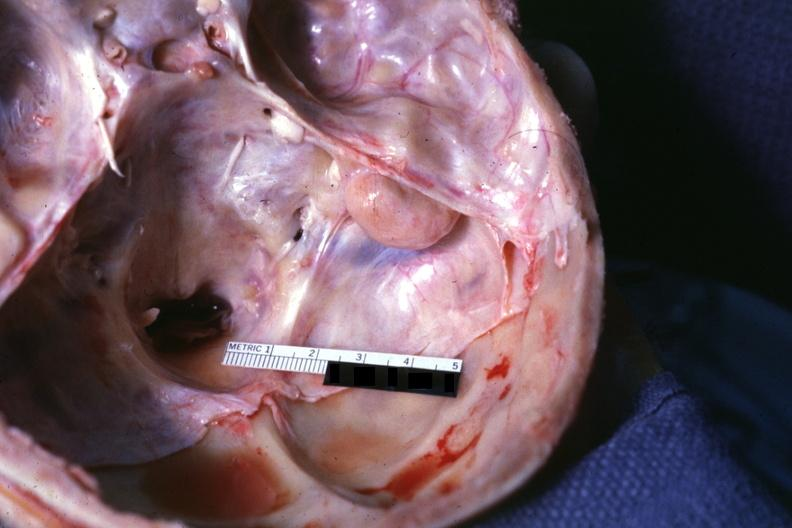what is lesion seen?
Answer the question using a single word or phrase. On surface right petrous bone 